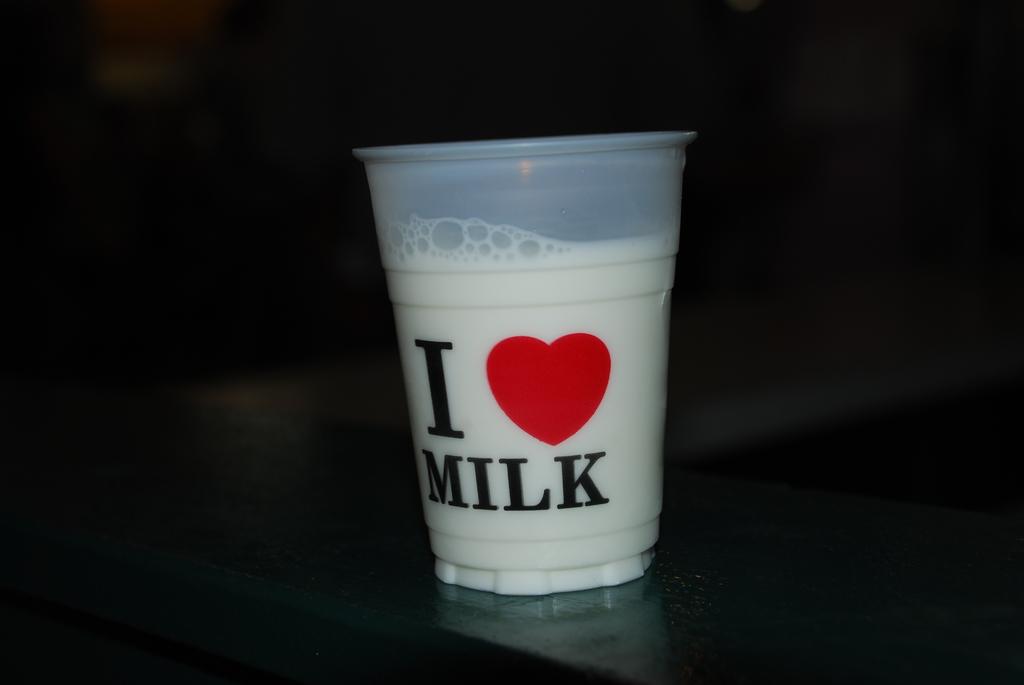What do they love?
Your response must be concise. Milk. This is a milkshake?
Your answer should be very brief. Answering does not require reading text in the image. 